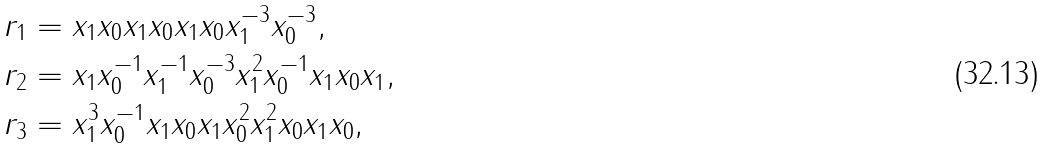Convert formula to latex. <formula><loc_0><loc_0><loc_500><loc_500>r _ { 1 } & = x _ { 1 } x _ { 0 } x _ { 1 } x _ { 0 } x _ { 1 } x _ { 0 } x _ { 1 } ^ { - 3 } x _ { 0 } ^ { - 3 } , \\ r _ { 2 } & = x _ { 1 } x _ { 0 } ^ { - 1 } x _ { 1 } ^ { - 1 } x _ { 0 } ^ { - 3 } x _ { 1 } ^ { 2 } x _ { 0 } ^ { - 1 } x _ { 1 } x _ { 0 } x _ { 1 } , \\ r _ { 3 } & = x _ { 1 } ^ { 3 } x _ { 0 } ^ { - 1 } x _ { 1 } x _ { 0 } x _ { 1 } x _ { 0 } ^ { 2 } x _ { 1 } ^ { 2 } x _ { 0 } x _ { 1 } x _ { 0 } ,</formula> 